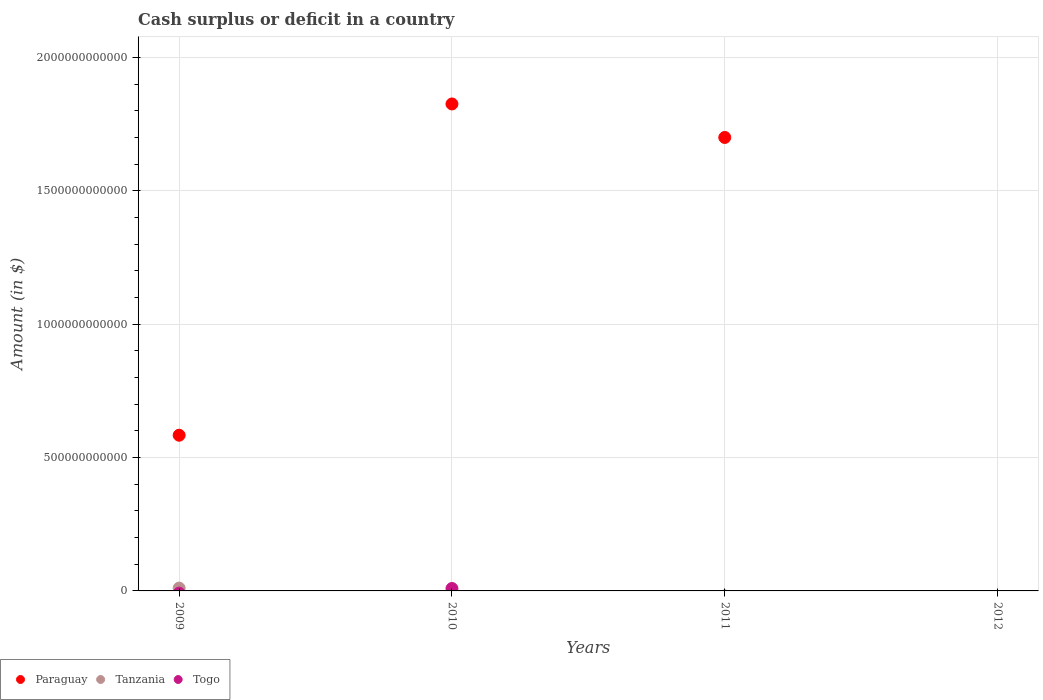Across all years, what is the maximum amount of cash surplus or deficit in Paraguay?
Provide a short and direct response. 1.83e+12. Across all years, what is the minimum amount of cash surplus or deficit in Tanzania?
Ensure brevity in your answer.  0. In which year was the amount of cash surplus or deficit in Tanzania maximum?
Keep it short and to the point. 2009. What is the total amount of cash surplus or deficit in Togo in the graph?
Give a very brief answer. 9.09e+09. What is the difference between the amount of cash surplus or deficit in Paraguay in 2009 and that in 2011?
Provide a short and direct response. -1.12e+12. What is the difference between the amount of cash surplus or deficit in Togo in 2011 and the amount of cash surplus or deficit in Tanzania in 2012?
Ensure brevity in your answer.  0. What is the average amount of cash surplus or deficit in Togo per year?
Provide a short and direct response. 2.27e+09. In the year 2009, what is the difference between the amount of cash surplus or deficit in Tanzania and amount of cash surplus or deficit in Paraguay?
Your answer should be compact. -5.73e+11. Is the amount of cash surplus or deficit in Paraguay in 2009 less than that in 2011?
Ensure brevity in your answer.  Yes. What is the difference between the highest and the second highest amount of cash surplus or deficit in Paraguay?
Provide a succinct answer. 1.26e+11. What is the difference between the highest and the lowest amount of cash surplus or deficit in Togo?
Offer a terse response. 9.09e+09. Is the sum of the amount of cash surplus or deficit in Paraguay in 2010 and 2011 greater than the maximum amount of cash surplus or deficit in Tanzania across all years?
Provide a short and direct response. Yes. Is it the case that in every year, the sum of the amount of cash surplus or deficit in Paraguay and amount of cash surplus or deficit in Tanzania  is greater than the amount of cash surplus or deficit in Togo?
Provide a short and direct response. No. Does the amount of cash surplus or deficit in Paraguay monotonically increase over the years?
Keep it short and to the point. No. Is the amount of cash surplus or deficit in Paraguay strictly greater than the amount of cash surplus or deficit in Tanzania over the years?
Ensure brevity in your answer.  Yes. How many dotlines are there?
Offer a terse response. 3. What is the difference between two consecutive major ticks on the Y-axis?
Provide a succinct answer. 5.00e+11. Does the graph contain any zero values?
Make the answer very short. Yes. Does the graph contain grids?
Make the answer very short. Yes. How many legend labels are there?
Give a very brief answer. 3. What is the title of the graph?
Provide a succinct answer. Cash surplus or deficit in a country. Does "Middle East & North Africa (all income levels)" appear as one of the legend labels in the graph?
Your response must be concise. No. What is the label or title of the Y-axis?
Offer a very short reply. Amount (in $). What is the Amount (in $) of Paraguay in 2009?
Your answer should be very brief. 5.84e+11. What is the Amount (in $) in Tanzania in 2009?
Your response must be concise. 1.07e+1. What is the Amount (in $) of Togo in 2009?
Offer a terse response. 0. What is the Amount (in $) of Paraguay in 2010?
Keep it short and to the point. 1.83e+12. What is the Amount (in $) of Tanzania in 2010?
Provide a succinct answer. 0. What is the Amount (in $) in Togo in 2010?
Provide a short and direct response. 9.09e+09. What is the Amount (in $) in Paraguay in 2011?
Make the answer very short. 1.70e+12. Across all years, what is the maximum Amount (in $) in Paraguay?
Offer a terse response. 1.83e+12. Across all years, what is the maximum Amount (in $) in Tanzania?
Your answer should be very brief. 1.07e+1. Across all years, what is the maximum Amount (in $) of Togo?
Your answer should be very brief. 9.09e+09. What is the total Amount (in $) in Paraguay in the graph?
Provide a short and direct response. 4.11e+12. What is the total Amount (in $) in Tanzania in the graph?
Give a very brief answer. 1.07e+1. What is the total Amount (in $) in Togo in the graph?
Make the answer very short. 9.09e+09. What is the difference between the Amount (in $) in Paraguay in 2009 and that in 2010?
Provide a short and direct response. -1.24e+12. What is the difference between the Amount (in $) in Paraguay in 2009 and that in 2011?
Make the answer very short. -1.12e+12. What is the difference between the Amount (in $) in Paraguay in 2010 and that in 2011?
Your answer should be very brief. 1.26e+11. What is the difference between the Amount (in $) in Paraguay in 2009 and the Amount (in $) in Togo in 2010?
Offer a terse response. 5.75e+11. What is the difference between the Amount (in $) in Tanzania in 2009 and the Amount (in $) in Togo in 2010?
Offer a very short reply. 1.57e+09. What is the average Amount (in $) in Paraguay per year?
Make the answer very short. 1.03e+12. What is the average Amount (in $) in Tanzania per year?
Make the answer very short. 2.67e+09. What is the average Amount (in $) of Togo per year?
Your answer should be compact. 2.27e+09. In the year 2009, what is the difference between the Amount (in $) in Paraguay and Amount (in $) in Tanzania?
Ensure brevity in your answer.  5.73e+11. In the year 2010, what is the difference between the Amount (in $) in Paraguay and Amount (in $) in Togo?
Keep it short and to the point. 1.82e+12. What is the ratio of the Amount (in $) in Paraguay in 2009 to that in 2010?
Offer a very short reply. 0.32. What is the ratio of the Amount (in $) of Paraguay in 2009 to that in 2011?
Provide a short and direct response. 0.34. What is the ratio of the Amount (in $) in Paraguay in 2010 to that in 2011?
Provide a succinct answer. 1.07. What is the difference between the highest and the second highest Amount (in $) in Paraguay?
Your answer should be compact. 1.26e+11. What is the difference between the highest and the lowest Amount (in $) in Paraguay?
Give a very brief answer. 1.83e+12. What is the difference between the highest and the lowest Amount (in $) of Tanzania?
Ensure brevity in your answer.  1.07e+1. What is the difference between the highest and the lowest Amount (in $) of Togo?
Provide a succinct answer. 9.09e+09. 